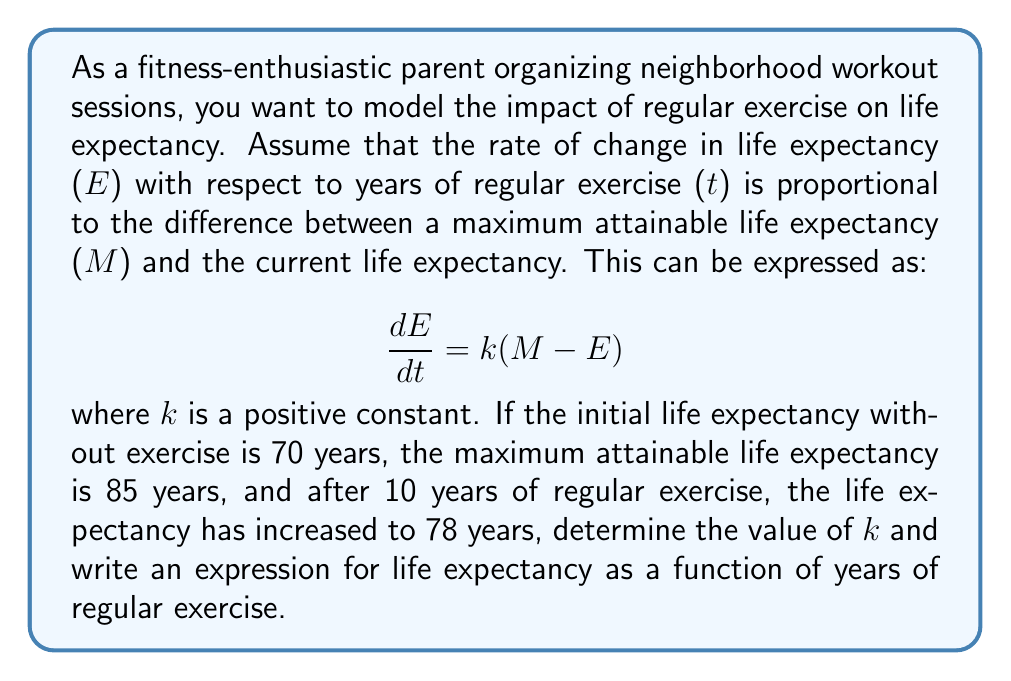Provide a solution to this math problem. To solve this problem, we'll follow these steps:

1) First, we need to solve the differential equation:
   $$\frac{dE}{dt} = k(M - E)$$

   This is a separable first-order differential equation. We can solve it as follows:

   $$\frac{dE}{M - E} = k dt$$

   Integrating both sides:

   $$-\ln|M - E| = kt + C$$

   Solving for E:

   $$E = M - Ce^{-kt}$$

2) Now we can use the initial condition: when t = 0, E = 70
   
   $$70 = 85 - Ce^{0}$$
   $$C = 15$$

   So our general solution is:

   $$E = 85 - 15e^{-kt}$$

3) To find k, we use the condition that after 10 years (t = 10), E = 78:

   $$78 = 85 - 15e^{-10k}$$
   $$7 = 15e^{-10k}$$
   $$\frac{7}{15} = e^{-10k}$$
   $$\ln(\frac{7}{15}) = -10k$$
   $$k = \frac{\ln(\frac{15}{7})}{10} \approx 0.0761$$

4) Therefore, the expression for life expectancy as a function of years of regular exercise is:

   $$E = 85 - 15e^{-0.0761t}$$

Where E is life expectancy in years and t is years of regular exercise.
Answer: k ≈ 0.0761
E = 85 - 15e^(-0.0761t) 